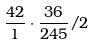Convert formula to latex. <formula><loc_0><loc_0><loc_500><loc_500>\frac { 4 2 } { 1 } \cdot \frac { 3 6 } { 2 4 5 } / 2</formula> 